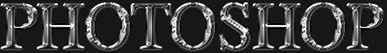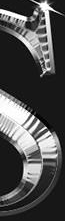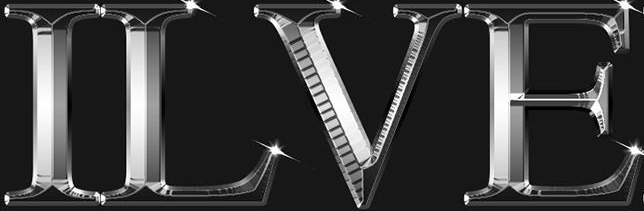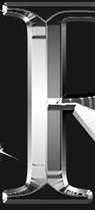What words are shown in these images in order, separated by a semicolon? PHOTOSHOP; #; ILVE; # 